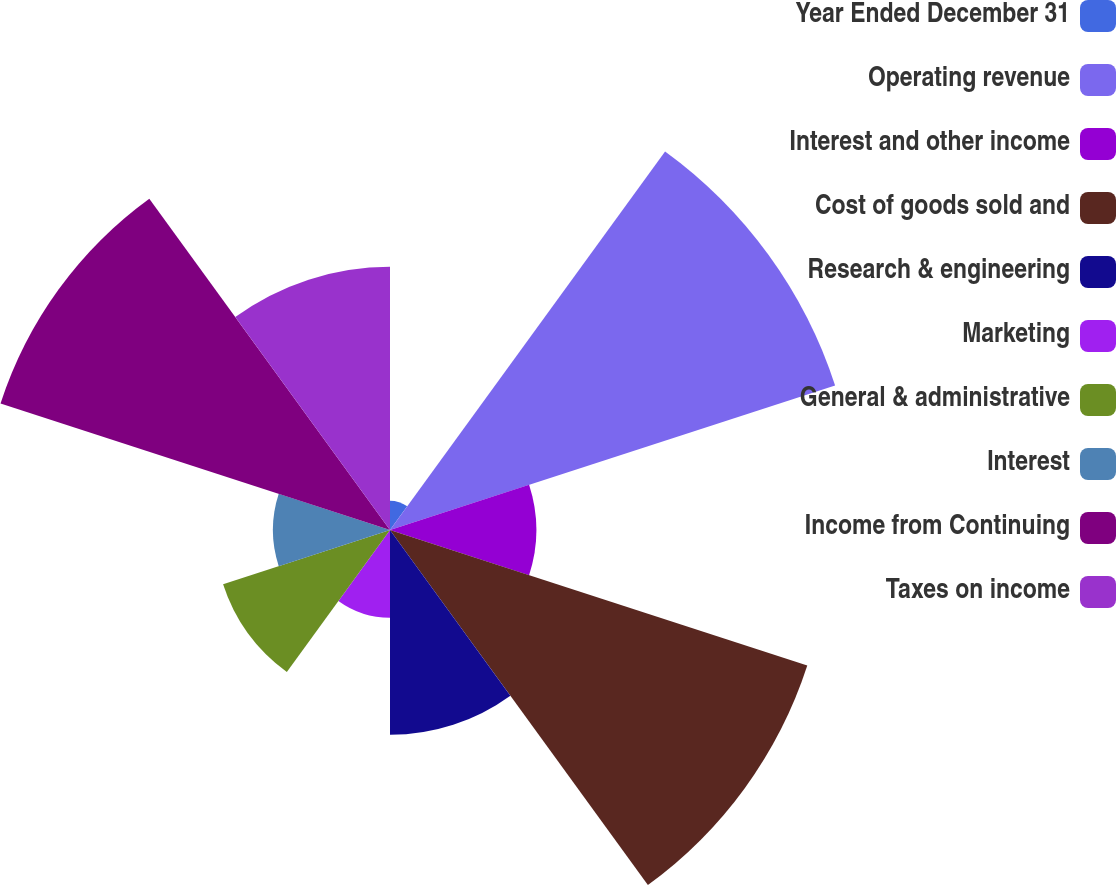Convert chart. <chart><loc_0><loc_0><loc_500><loc_500><pie_chart><fcel>Year Ended December 31<fcel>Operating revenue<fcel>Interest and other income<fcel>Cost of goods sold and<fcel>Research & engineering<fcel>Marketing<fcel>General & administrative<fcel>Interest<fcel>Income from Continuing<fcel>Taxes on income<nl><fcel>1.25%<fcel>20.0%<fcel>6.25%<fcel>18.75%<fcel>8.75%<fcel>3.75%<fcel>7.5%<fcel>5.0%<fcel>17.5%<fcel>11.25%<nl></chart> 